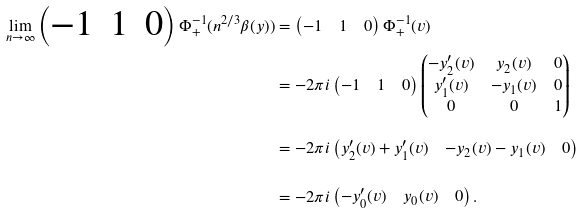<formula> <loc_0><loc_0><loc_500><loc_500>\lim _ { n \to \infty } \begin{pmatrix} - 1 & 1 & 0 \end{pmatrix} \Phi _ { + } ^ { - 1 } ( n ^ { 2 / 3 } \beta ( y ) ) & = \begin{pmatrix} - 1 & 1 & 0 \end{pmatrix} \Phi _ { + } ^ { - 1 } ( v ) \\ & = - 2 \pi i \begin{pmatrix} - 1 & 1 & 0 \end{pmatrix} \begin{pmatrix} - y _ { 2 } ^ { \prime } ( v ) & y _ { 2 } ( v ) & 0 \\ y _ { 1 } ^ { \prime } ( v ) & - y _ { 1 } ( v ) & 0 \\ 0 & 0 & 1 \end{pmatrix} \\ & = - 2 \pi i \begin{pmatrix} y _ { 2 } ^ { \prime } ( v ) + y _ { 1 } ^ { \prime } ( v ) & - y _ { 2 } ( v ) - y _ { 1 } ( v ) & 0 \end{pmatrix} \\ & = - 2 \pi i \begin{pmatrix} - y _ { 0 } ^ { \prime } ( v ) & y _ { 0 } ( v ) & 0 \end{pmatrix} .</formula> 